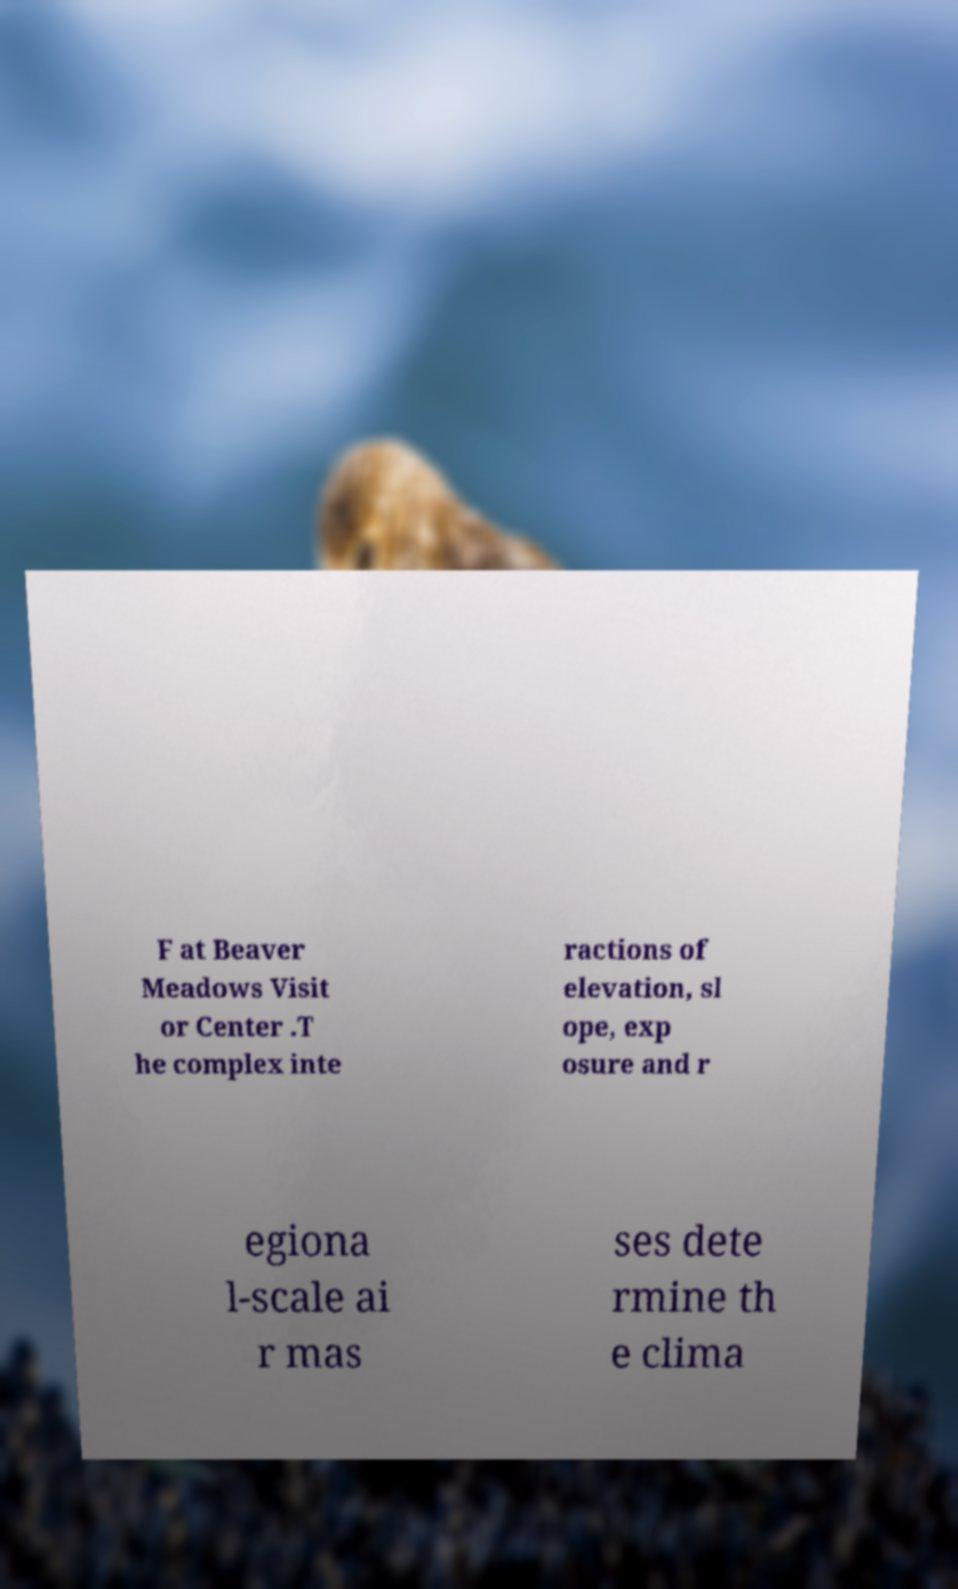Could you assist in decoding the text presented in this image and type it out clearly? F at Beaver Meadows Visit or Center .T he complex inte ractions of elevation, sl ope, exp osure and r egiona l-scale ai r mas ses dete rmine th e clima 